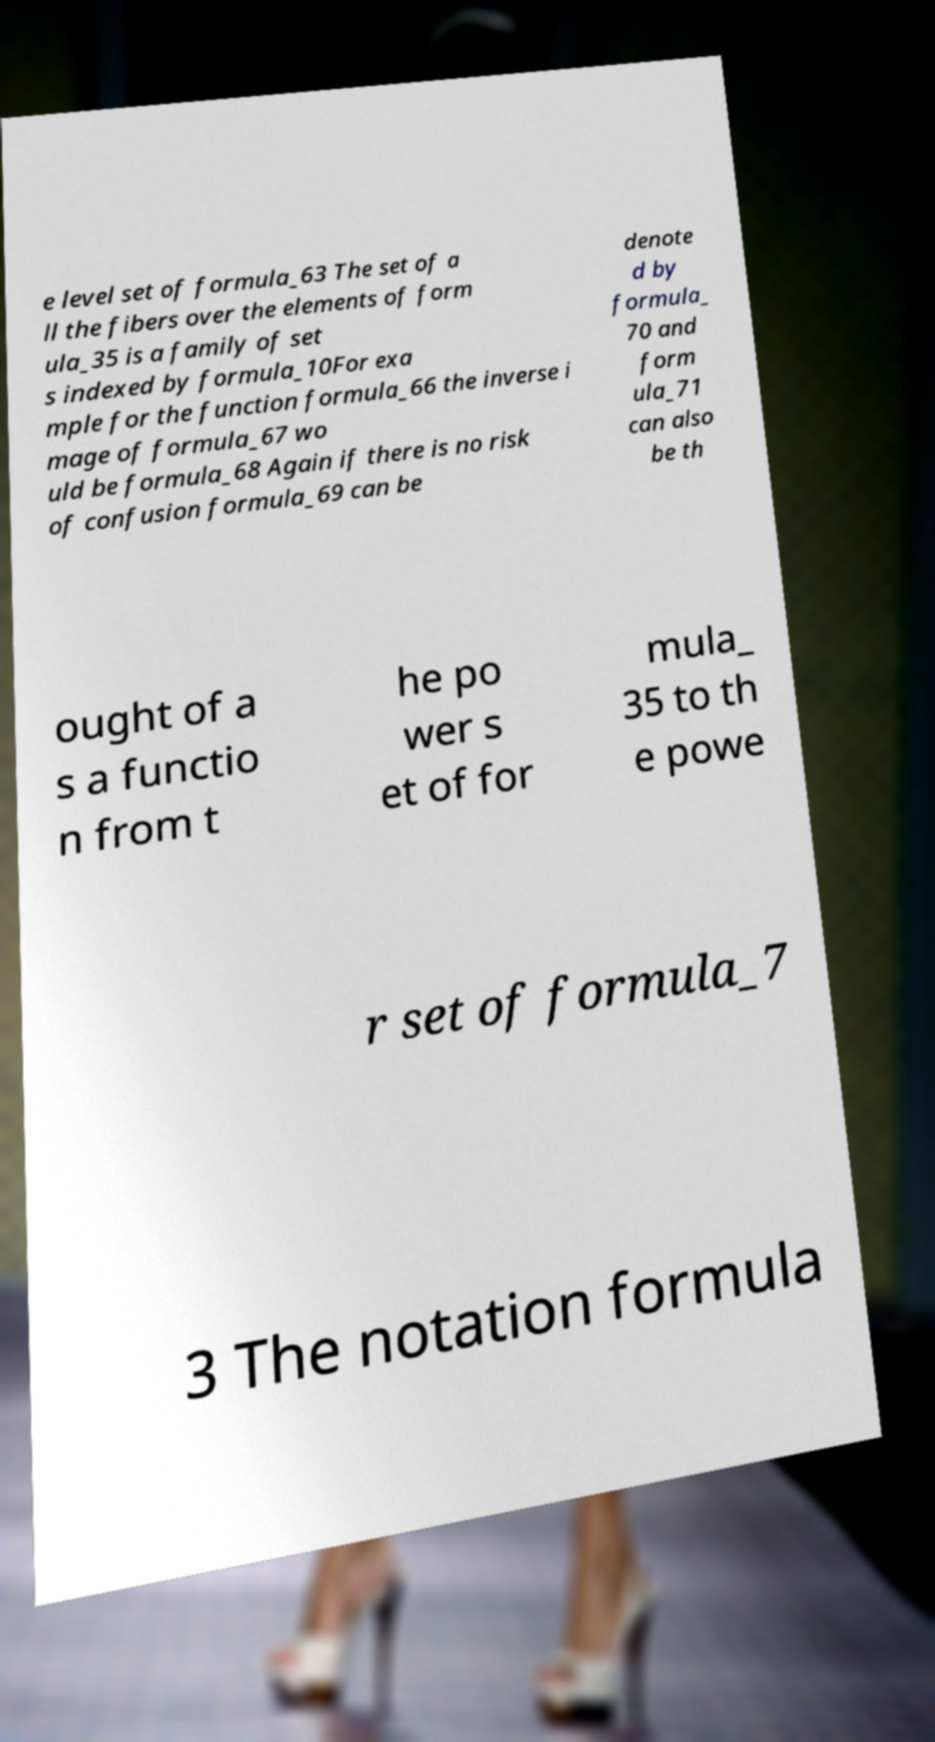Please read and relay the text visible in this image. What does it say? e level set of formula_63 The set of a ll the fibers over the elements of form ula_35 is a family of set s indexed by formula_10For exa mple for the function formula_66 the inverse i mage of formula_67 wo uld be formula_68 Again if there is no risk of confusion formula_69 can be denote d by formula_ 70 and form ula_71 can also be th ought of a s a functio n from t he po wer s et of for mula_ 35 to th e powe r set of formula_7 3 The notation formula 